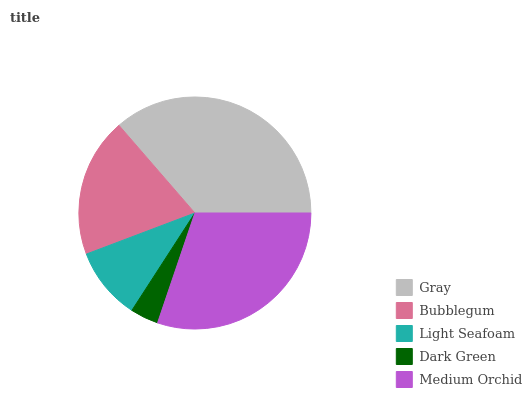Is Dark Green the minimum?
Answer yes or no. Yes. Is Gray the maximum?
Answer yes or no. Yes. Is Bubblegum the minimum?
Answer yes or no. No. Is Bubblegum the maximum?
Answer yes or no. No. Is Gray greater than Bubblegum?
Answer yes or no. Yes. Is Bubblegum less than Gray?
Answer yes or no. Yes. Is Bubblegum greater than Gray?
Answer yes or no. No. Is Gray less than Bubblegum?
Answer yes or no. No. Is Bubblegum the high median?
Answer yes or no. Yes. Is Bubblegum the low median?
Answer yes or no. Yes. Is Dark Green the high median?
Answer yes or no. No. Is Medium Orchid the low median?
Answer yes or no. No. 